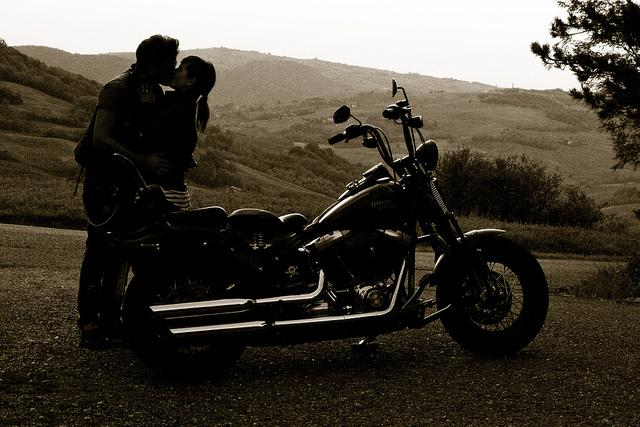What are the two feeling right now? love 